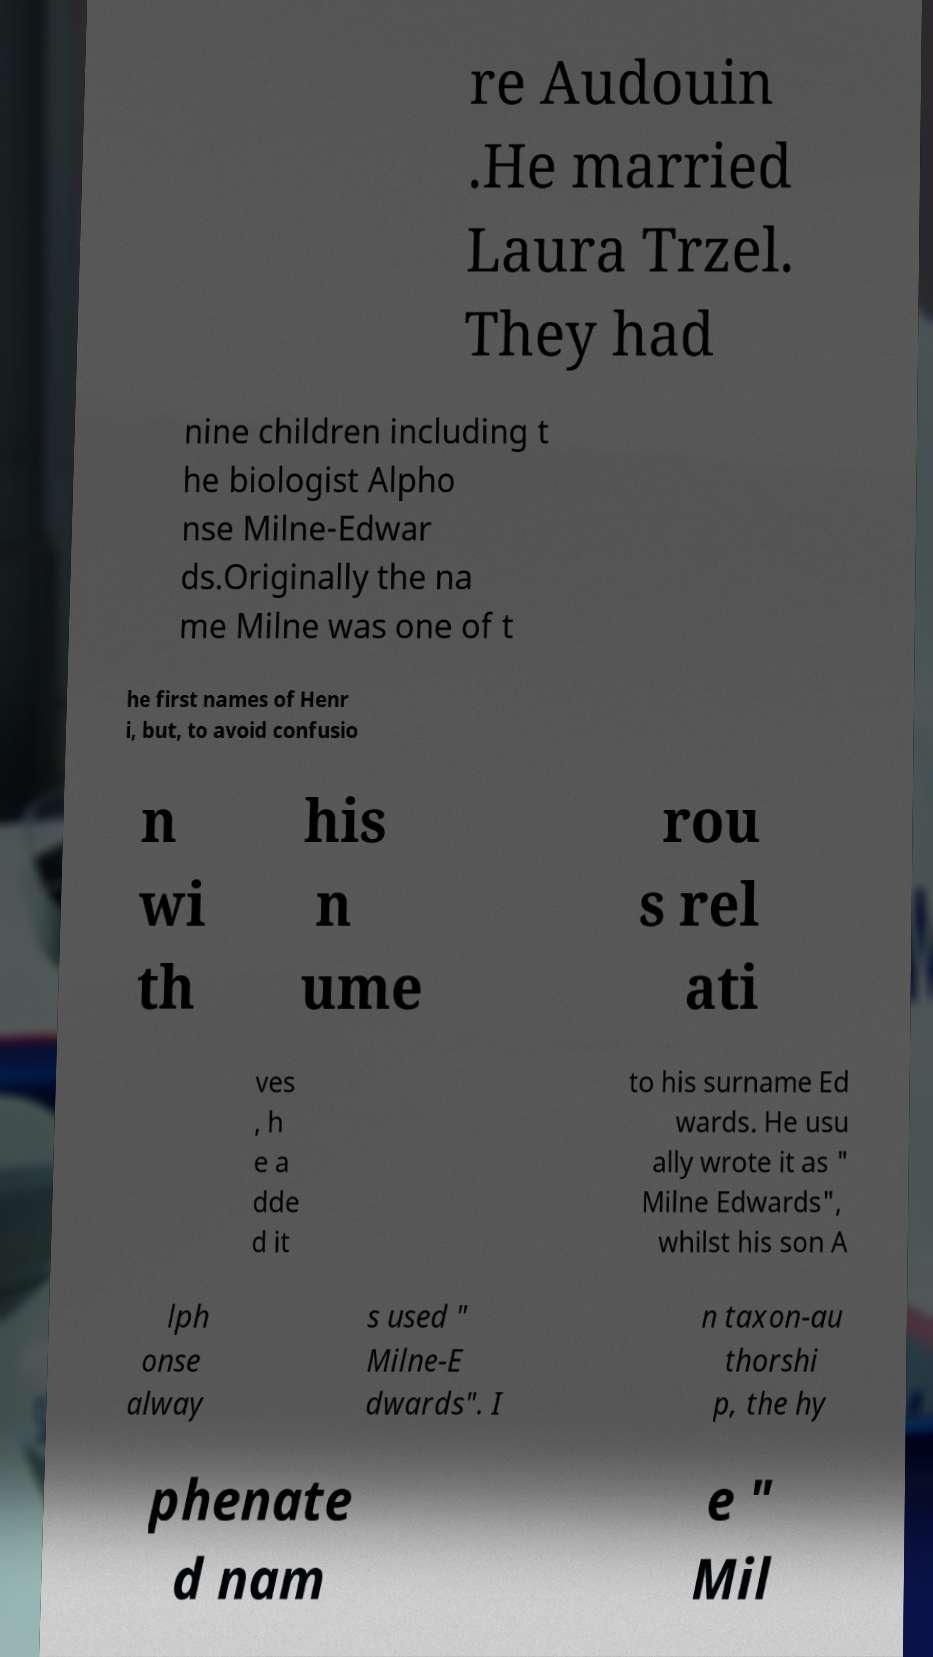Please read and relay the text visible in this image. What does it say? re Audouin .He married Laura Trzel. They had nine children including t he biologist Alpho nse Milne-Edwar ds.Originally the na me Milne was one of t he first names of Henr i, but, to avoid confusio n wi th his n ume rou s rel ati ves , h e a dde d it to his surname Ed wards. He usu ally wrote it as " Milne Edwards", whilst his son A lph onse alway s used " Milne-E dwards". I n taxon-au thorshi p, the hy phenate d nam e " Mil 